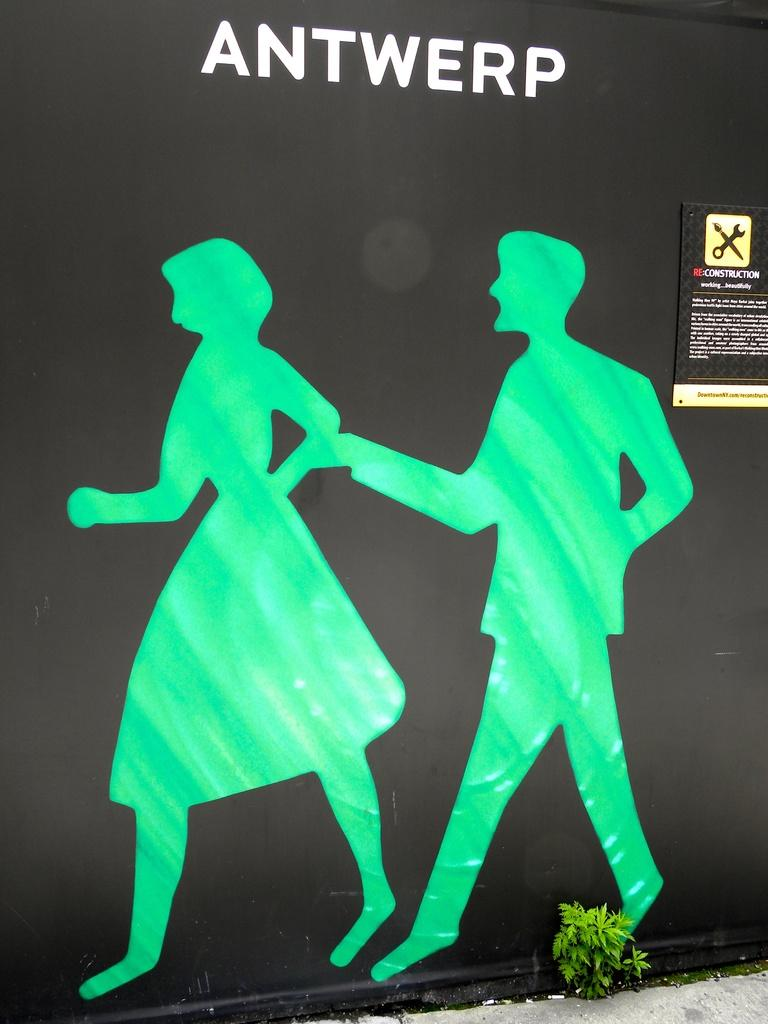Provide a one-sentence caption for the provided image. Two silhouettes in green are on a black background with the word ANTWERP over their head. 